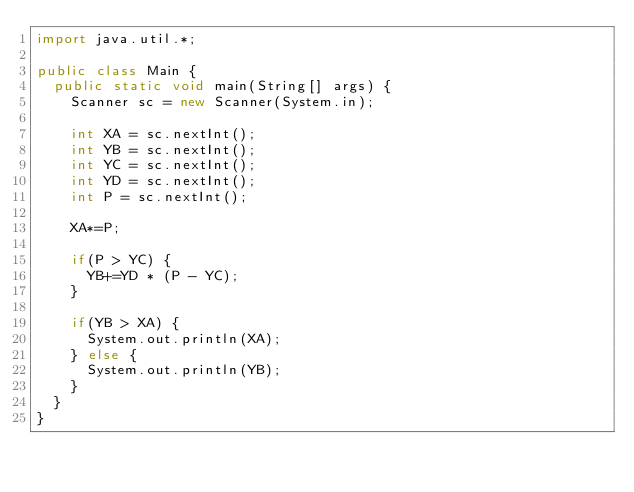<code> <loc_0><loc_0><loc_500><loc_500><_Java_>import java.util.*;

public class Main {
	public static void main(String[] args) {
		Scanner sc = new Scanner(System.in);

		int XA = sc.nextInt();
		int YB = sc.nextInt();
		int YC = sc.nextInt();
		int YD = sc.nextInt();
		int P = sc.nextInt();
		
		XA*=P;
		
		if(P > YC) {
			YB+=YD * (P - YC);
		}
		
		if(YB > XA) {
			System.out.println(XA);
		} else {
			System.out.println(YB);
		}
	}
}</code> 